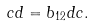<formula> <loc_0><loc_0><loc_500><loc_500>c d = b _ { 1 2 } d c .</formula> 